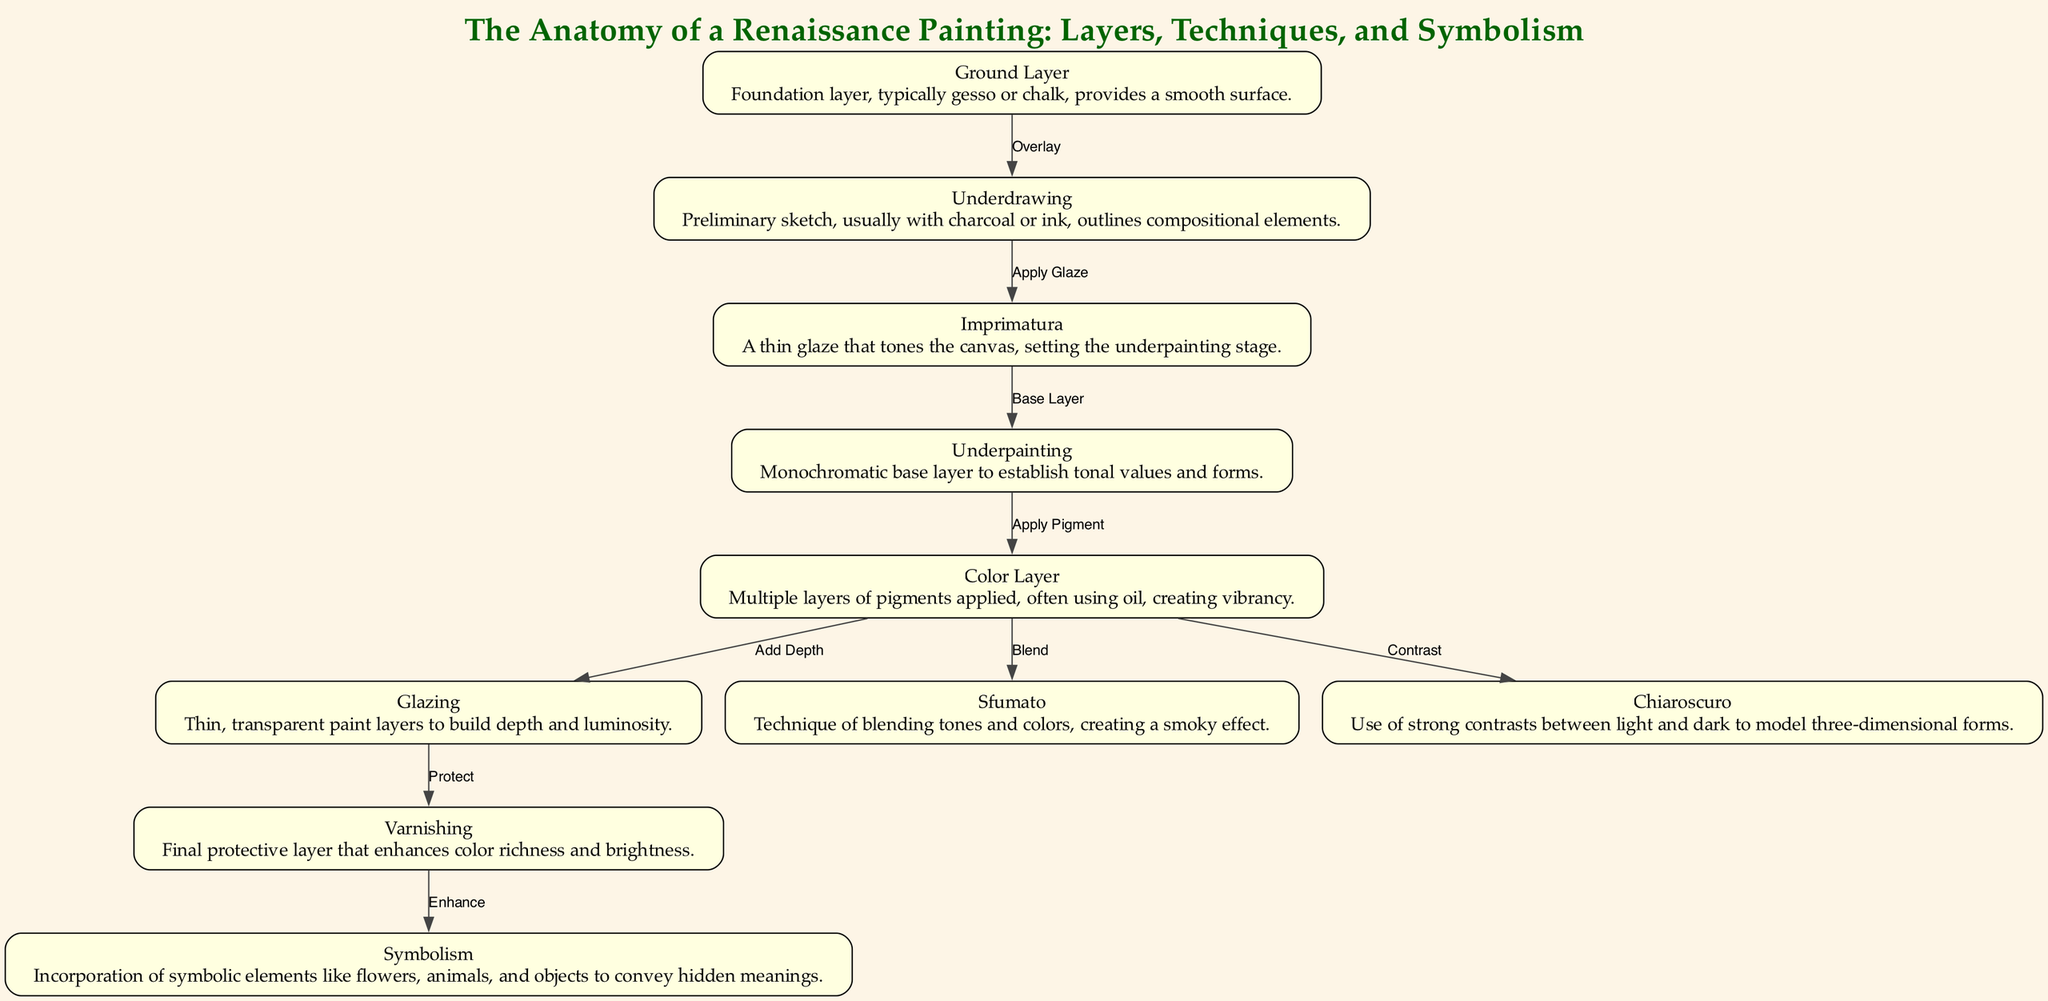What is the foundation layer in a Renaissance painting? The diagram indicates that the foundation layer is the "Ground Layer," which is typically made of gesso or chalk and provides a smooth surface for painting.
Answer: Ground Layer How many techniques are described in the diagram? By counting the nodes representing techniques in the diagram — Sfumato, Chiaroscuro, and Symbolism — there are three distinct techniques depicted.
Answer: 3 What layer is applied after the Underdrawing? According to the diagram, after the Underdrawing, the next layer applied is the Imprimatura, which is a thin glaze that tones the canvas.
Answer: Imprimatura Which layer establishes tonal values and forms? The diagram states that the Underpainting is responsible for establishing tonal values and forms as it is a monochromatic base layer applied after the Imprimatura.
Answer: Underpainting What is the final protective layer of a Renaissance painting? The diagram clearly identifies Varnishing as the final protective layer that enhances color richness and brightness in a Renaissance painting.
Answer: Varnishing Which technique utilizes strong contrasts between light and dark? The Chiaroscuro technique is mentioned in the diagram as the method that uses strong contrasts to model three-dimensional forms.
Answer: Chiaroscuro What connects the Color Layer to the Glazing? The connection from the Color Layer to Glazing is described as "Add Depth," indicating that glazing involves the addition of transparent paint layers to create depth and luminosity.
Answer: Add Depth What is the purpose of the Symbolism in the painting? Symbolism is incorporated in the painting to convey hidden meanings through symbolic elements like flowers, animals, and objects, as described in the diagram.
Answer: Hidden meanings What layer follows the Color Layer in the painting process? The diagram details that after the Color Layer, the next layer applied is Glazing, emphasizing the process of adding depth and luminosity.
Answer: Glazing 